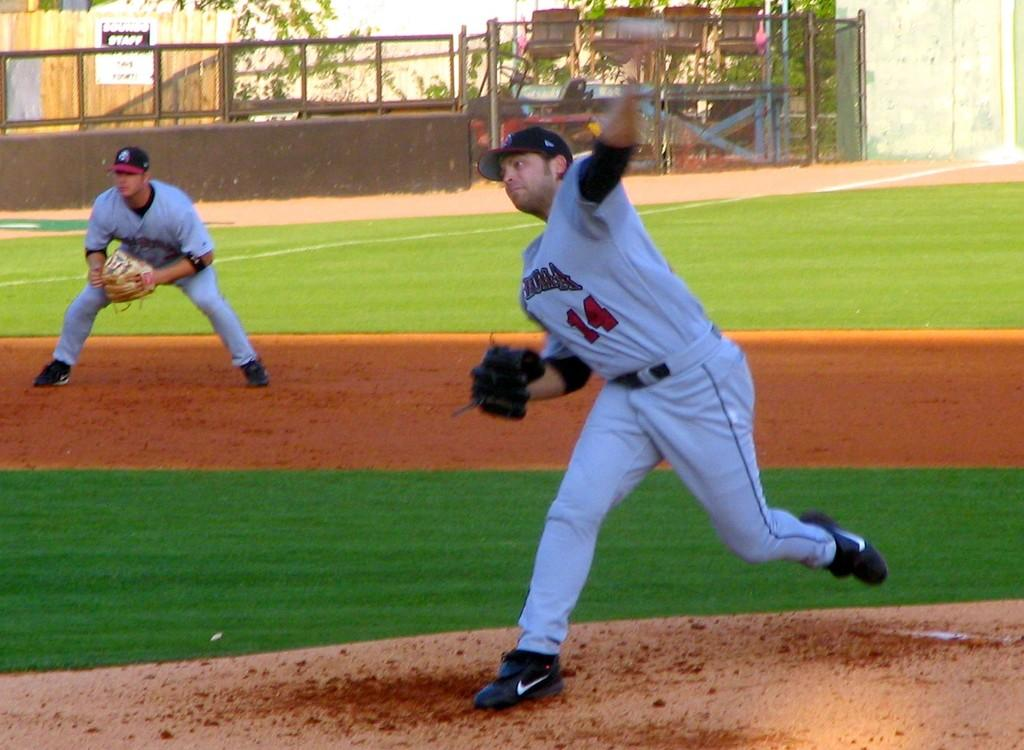<image>
Render a clear and concise summary of the photo. pitcher wearing number 14 throws the ball while another player is bent over waiting 